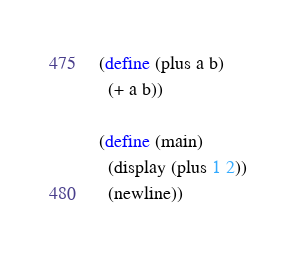Convert code to text. <code><loc_0><loc_0><loc_500><loc_500><_Scheme_>(define (plus a b)
  (+ a b))

(define (main)
  (display (plus 1 2))
  (newline))
</code> 